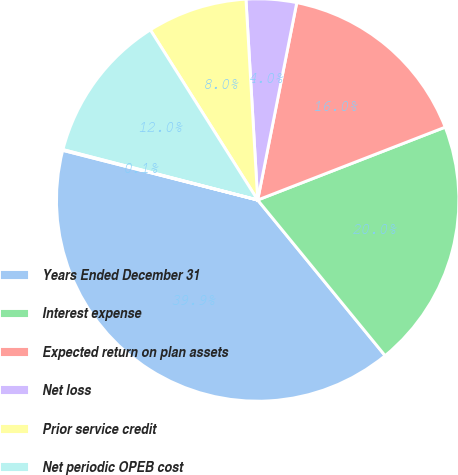Convert chart to OTSL. <chart><loc_0><loc_0><loc_500><loc_500><pie_chart><fcel>Years Ended December 31<fcel>Interest expense<fcel>Expected return on plan assets<fcel>Net loss<fcel>Prior service credit<fcel>Net periodic OPEB cost<fcel>Regulatory adjustment(a)<nl><fcel>39.89%<fcel>19.98%<fcel>15.99%<fcel>4.04%<fcel>8.03%<fcel>12.01%<fcel>0.06%<nl></chart> 